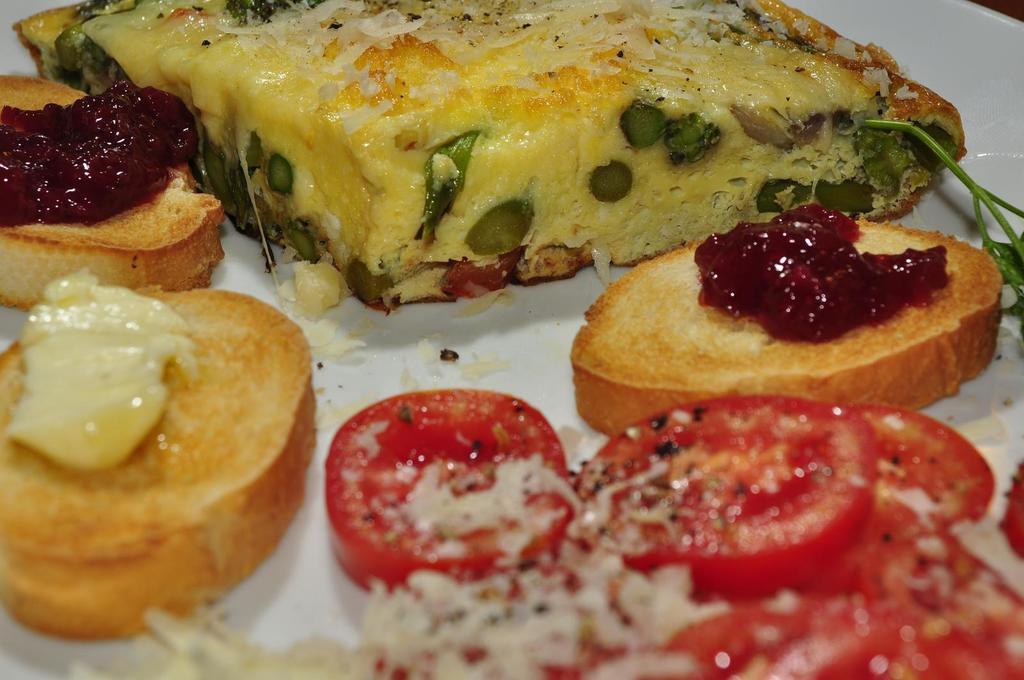Please provide a concise description of this image. In this image there are some food items kept in a white color bowl as we can see in middle of this image. 